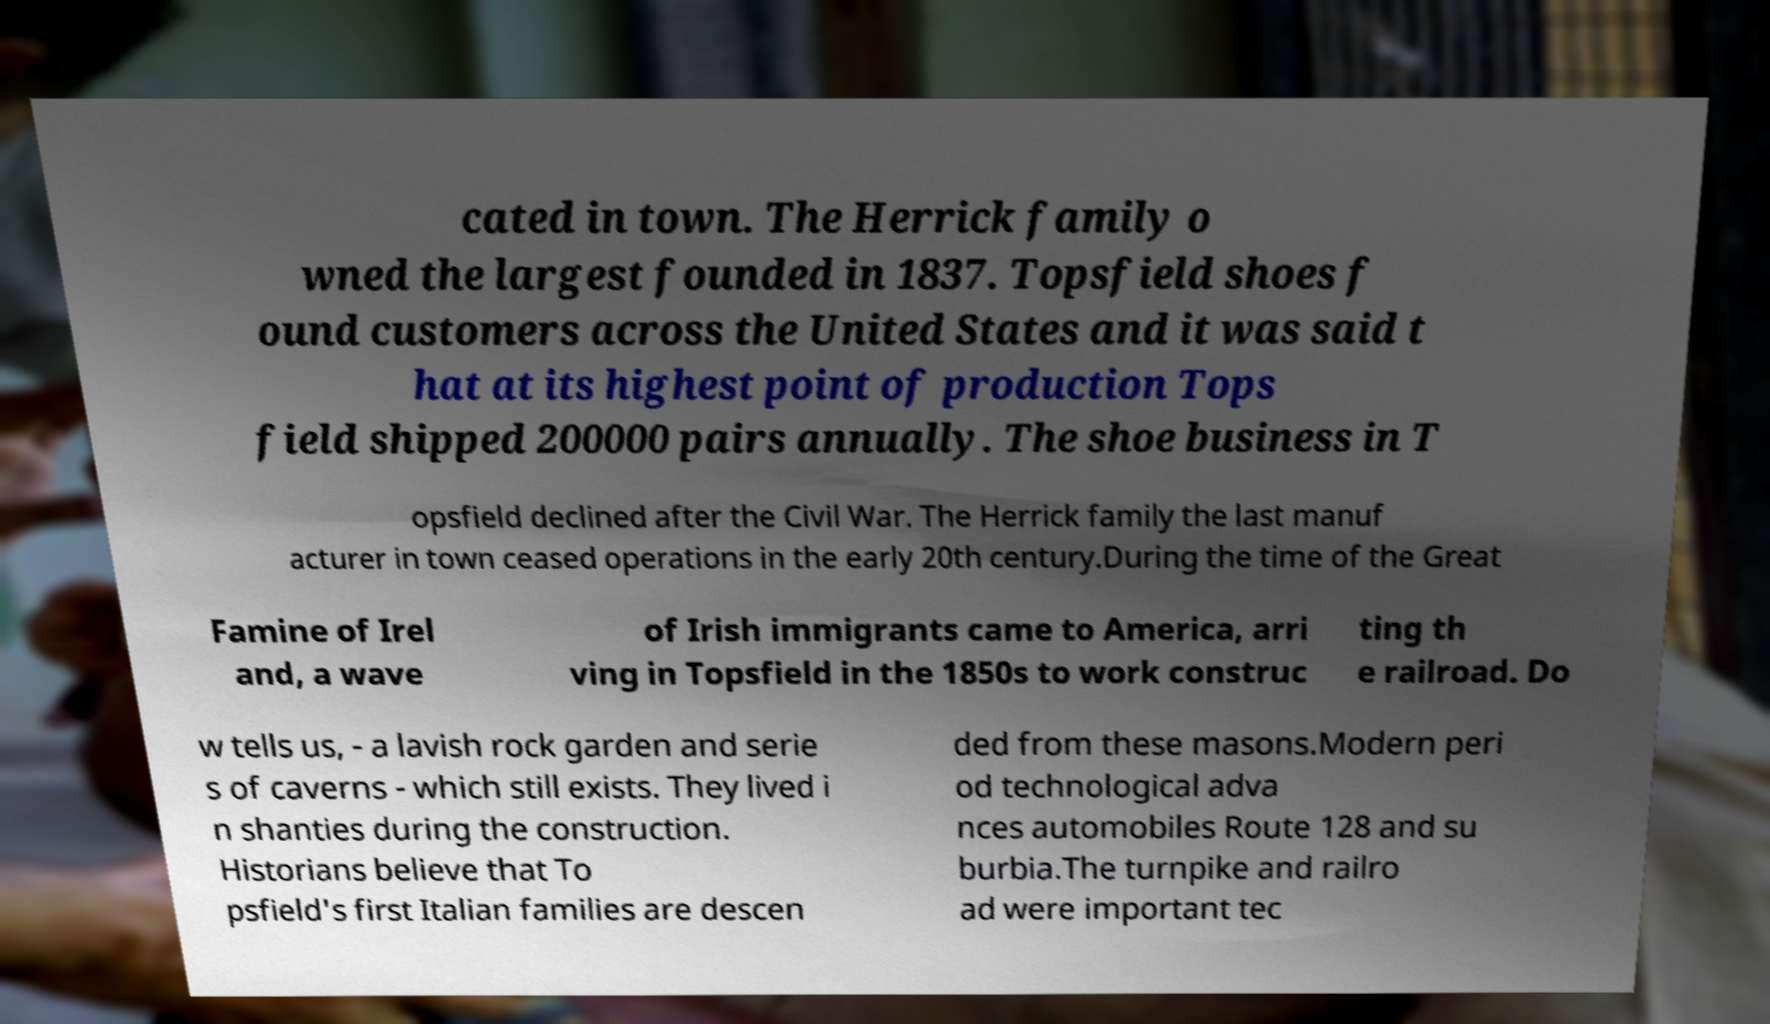Could you assist in decoding the text presented in this image and type it out clearly? cated in town. The Herrick family o wned the largest founded in 1837. Topsfield shoes f ound customers across the United States and it was said t hat at its highest point of production Tops field shipped 200000 pairs annually. The shoe business in T opsfield declined after the Civil War. The Herrick family the last manuf acturer in town ceased operations in the early 20th century.During the time of the Great Famine of Irel and, a wave of Irish immigrants came to America, arri ving in Topsfield in the 1850s to work construc ting th e railroad. Do w tells us, - a lavish rock garden and serie s of caverns - which still exists. They lived i n shanties during the construction. Historians believe that To psfield's first Italian families are descen ded from these masons.Modern peri od technological adva nces automobiles Route 128 and su burbia.The turnpike and railro ad were important tec 